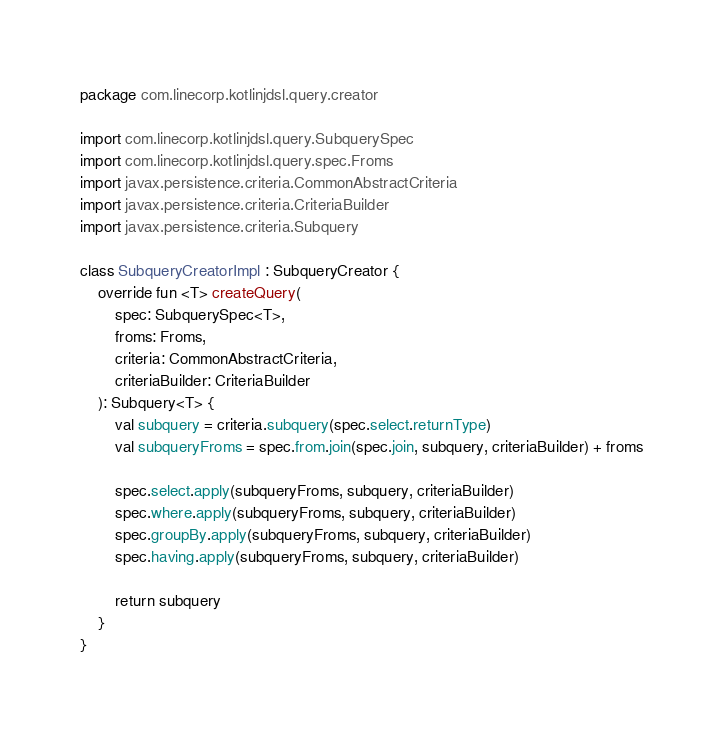<code> <loc_0><loc_0><loc_500><loc_500><_Kotlin_>package com.linecorp.kotlinjdsl.query.creator

import com.linecorp.kotlinjdsl.query.SubquerySpec
import com.linecorp.kotlinjdsl.query.spec.Froms
import javax.persistence.criteria.CommonAbstractCriteria
import javax.persistence.criteria.CriteriaBuilder
import javax.persistence.criteria.Subquery

class SubqueryCreatorImpl : SubqueryCreator {
    override fun <T> createQuery(
        spec: SubquerySpec<T>,
        froms: Froms,
        criteria: CommonAbstractCriteria,
        criteriaBuilder: CriteriaBuilder
    ): Subquery<T> {
        val subquery = criteria.subquery(spec.select.returnType)
        val subqueryFroms = spec.from.join(spec.join, subquery, criteriaBuilder) + froms

        spec.select.apply(subqueryFroms, subquery, criteriaBuilder)
        spec.where.apply(subqueryFroms, subquery, criteriaBuilder)
        spec.groupBy.apply(subqueryFroms, subquery, criteriaBuilder)
        spec.having.apply(subqueryFroms, subquery, criteriaBuilder)

        return subquery
    }
}
</code> 